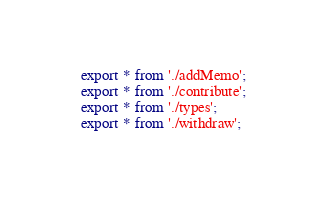Convert code to text. <code><loc_0><loc_0><loc_500><loc_500><_TypeScript_>export * from './addMemo';
export * from './contribute';
export * from './types';
export * from './withdraw';
</code> 